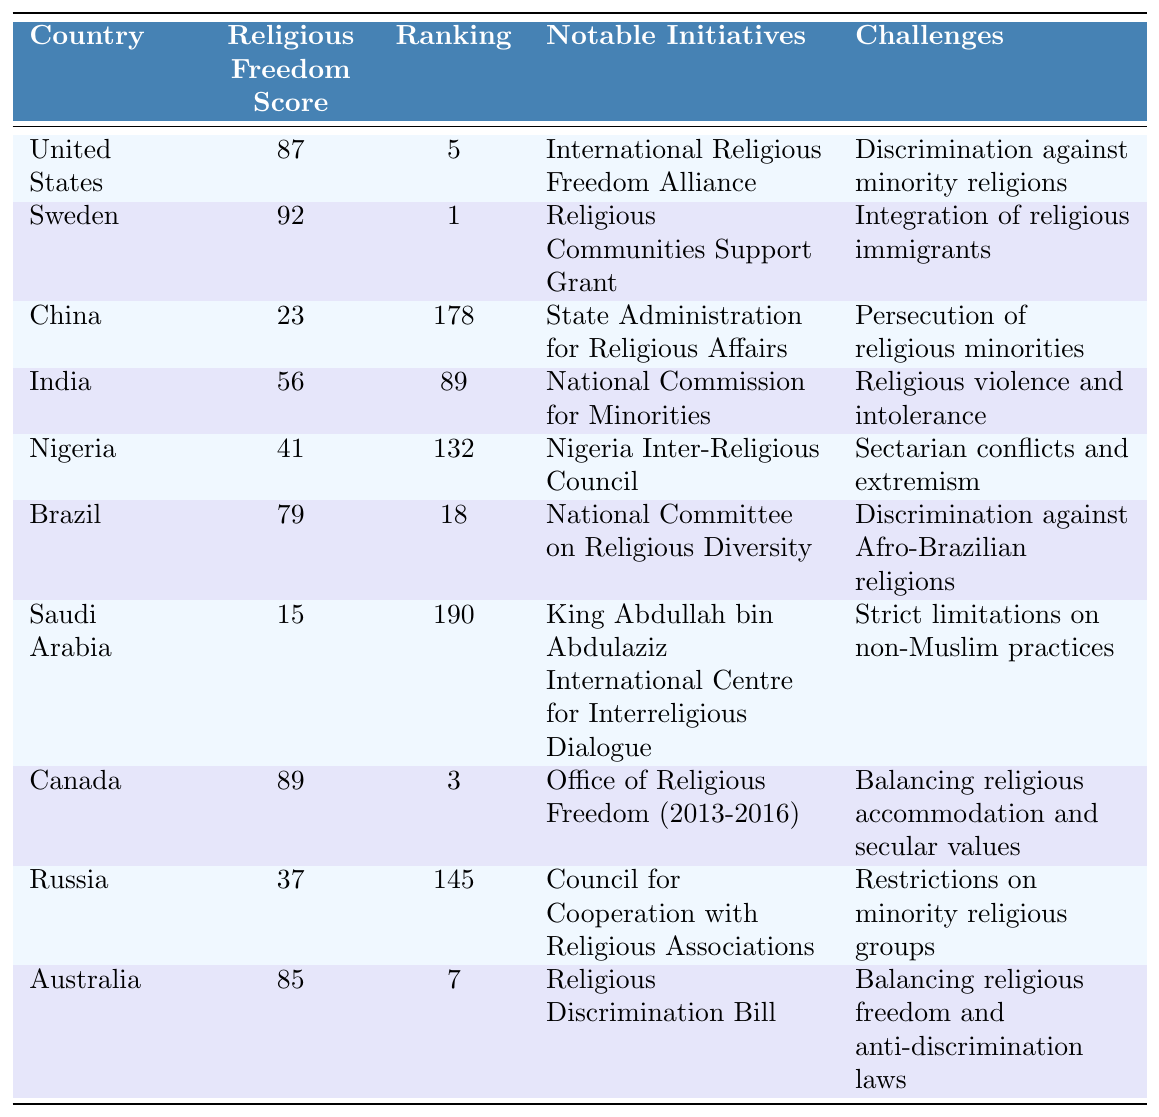What is the highest Global Religious Freedom Index Score among the countries listed? The table shows scores for various countries, with Sweden having the highest score of 92.
Answer: 92 Which country ranks 1st in the Global Religious Freedom Index? According to the table, Sweden is ranked 1st.
Answer: Sweden What notable initiative is associated with Canada regarding religious freedom? The table lists the Office of Religious Freedom (2013-2016) as Canada's notable initiative.
Answer: Office of Religious Freedom (2013-2016) Is the United States facing challenges regarding religious freedom? Yes, the table indicates that the United States faces discrimination against minority religions as a challenge.
Answer: Yes How many countries have a religious freedom score above 80? By checking the scores in the table, Sweden (92), Canada (89), and the United States (87) have scores above 80. That's 3 countries.
Answer: 3 What is the difference in Global Religious Freedom Index Scores between Sweden and Saudi Arabia? Sweden has a score of 92 and Saudi Arabia has a score of 15. The difference is 92 - 15 = 77.
Answer: 77 Which country has the lowest ranking in the Global Religious Freedom Index? The table indicates that Saudi Arabia has the lowest ranking at 190.
Answer: Saudi Arabia Are there any notable initiatives in China to promote religious freedom? The table lists the State Administration for Religious Affairs as a notable initiative in China, but it is accompanied by the challenge of persecution of religious minorities.
Answer: Yes Which country has a higher score: Nigeria or India? Nigeria has a score of 41, while India has a score of 56. Since 56 is greater than 41, India has a higher score.
Answer: India If we average the Global Religious Freedom Index Scores of all listed countries, what is the result? We sum the scores: 87 + 92 + 23 + 56 + 41 + 79 + 15 + 89 + 37 + 85 = 504. There are 10 countries, so the average is 504 / 10 = 50.4.
Answer: 50.4 